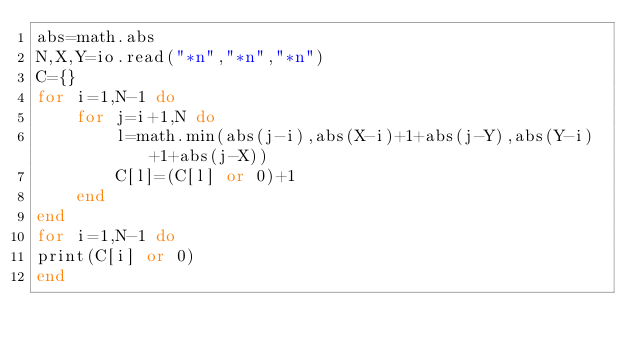<code> <loc_0><loc_0><loc_500><loc_500><_Lua_>abs=math.abs
N,X,Y=io.read("*n","*n","*n")
C={}
for i=1,N-1 do
	for j=i+1,N do
		l=math.min(abs(j-i),abs(X-i)+1+abs(j-Y),abs(Y-i)+1+abs(j-X))
		C[l]=(C[l] or 0)+1
	end
end
for i=1,N-1 do
print(C[i] or 0)
end</code> 